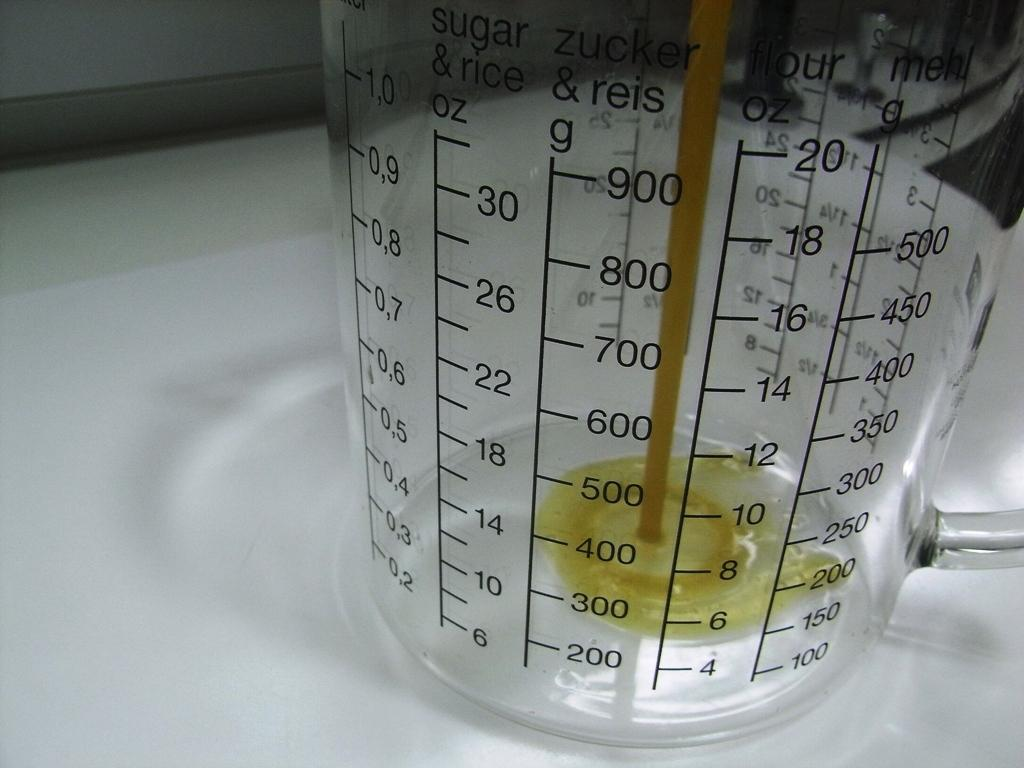<image>
Write a terse but informative summary of the picture. Yellow liquid is being poured into a cup that has sugar and rice oz as a heading. 